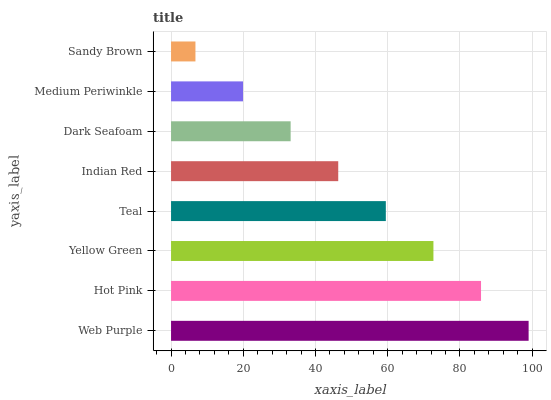Is Sandy Brown the minimum?
Answer yes or no. Yes. Is Web Purple the maximum?
Answer yes or no. Yes. Is Hot Pink the minimum?
Answer yes or no. No. Is Hot Pink the maximum?
Answer yes or no. No. Is Web Purple greater than Hot Pink?
Answer yes or no. Yes. Is Hot Pink less than Web Purple?
Answer yes or no. Yes. Is Hot Pink greater than Web Purple?
Answer yes or no. No. Is Web Purple less than Hot Pink?
Answer yes or no. No. Is Teal the high median?
Answer yes or no. Yes. Is Indian Red the low median?
Answer yes or no. Yes. Is Sandy Brown the high median?
Answer yes or no. No. Is Yellow Green the low median?
Answer yes or no. No. 